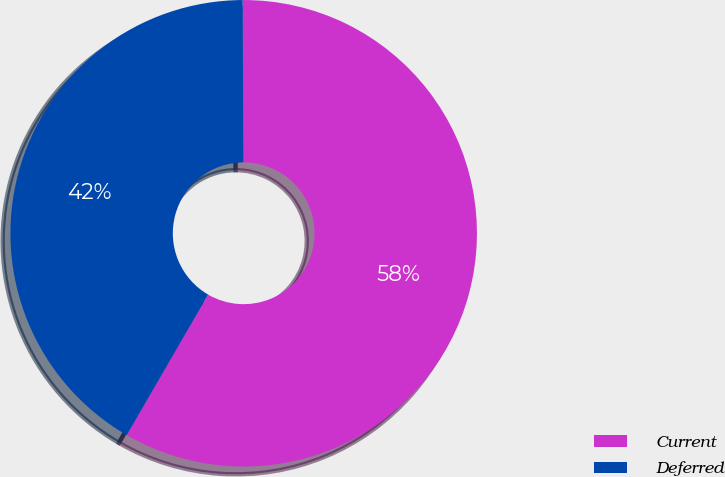Convert chart to OTSL. <chart><loc_0><loc_0><loc_500><loc_500><pie_chart><fcel>Current<fcel>Deferred<nl><fcel>58.43%<fcel>41.57%<nl></chart> 